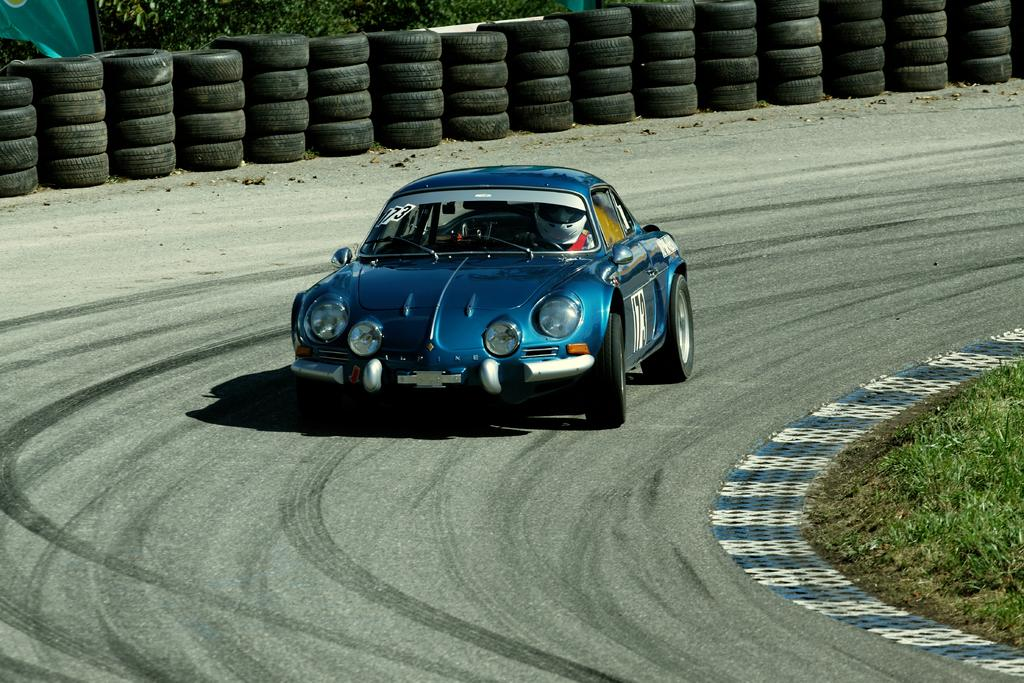What color is the car in the image? The car in the image is blue. What is the car doing in the image? The car is moving on the road. What type of vegetation can be seen in the image? There is grass visible in the image. What type of road feature can be seen in the image? There are turns visible in the image. What color is the cloth in the image? The cloth in the image is green. What can be seen in the background of the image? There are trees in the background of the image. What type of animals can be seen at the zoo in the image? There is no zoo present in the image, so it is not possible to determine what type of animals might be seen there. 